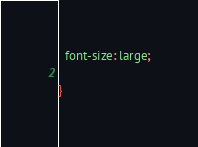<code> <loc_0><loc_0><loc_500><loc_500><_CSS_>  font-size: large;

}
</code> 